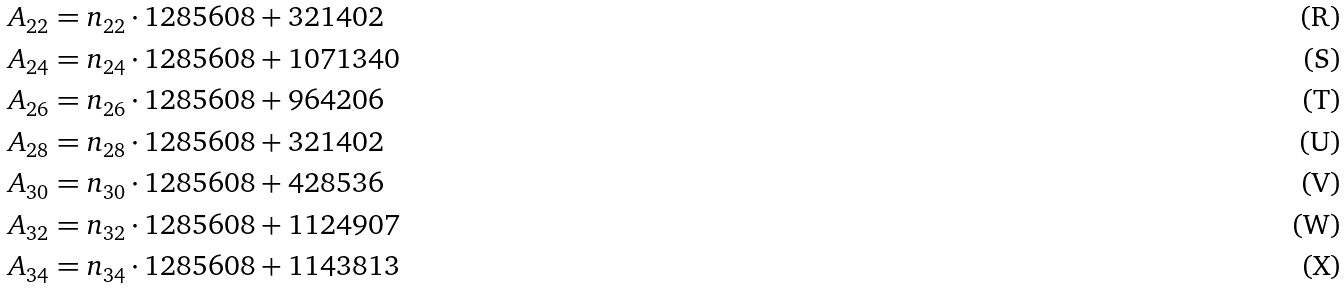<formula> <loc_0><loc_0><loc_500><loc_500>A _ { 2 2 } & = n _ { 2 2 } \cdot 1 2 8 5 6 0 8 + 3 2 1 4 0 2 \\ A _ { 2 4 } & = n _ { 2 4 } \cdot 1 2 8 5 6 0 8 + 1 0 7 1 3 4 0 \\ A _ { 2 6 } & = n _ { 2 6 } \cdot 1 2 8 5 6 0 8 + 9 6 4 2 0 6 \\ A _ { 2 8 } & = n _ { 2 8 } \cdot 1 2 8 5 6 0 8 + 3 2 1 4 0 2 \\ A _ { 3 0 } & = n _ { 3 0 } \cdot 1 2 8 5 6 0 8 + 4 2 8 5 3 6 \\ A _ { 3 2 } & = n _ { 3 2 } \cdot 1 2 8 5 6 0 8 + 1 1 2 4 9 0 7 \\ A _ { 3 4 } & = n _ { 3 4 } \cdot 1 2 8 5 6 0 8 + 1 1 4 3 8 1 3</formula> 